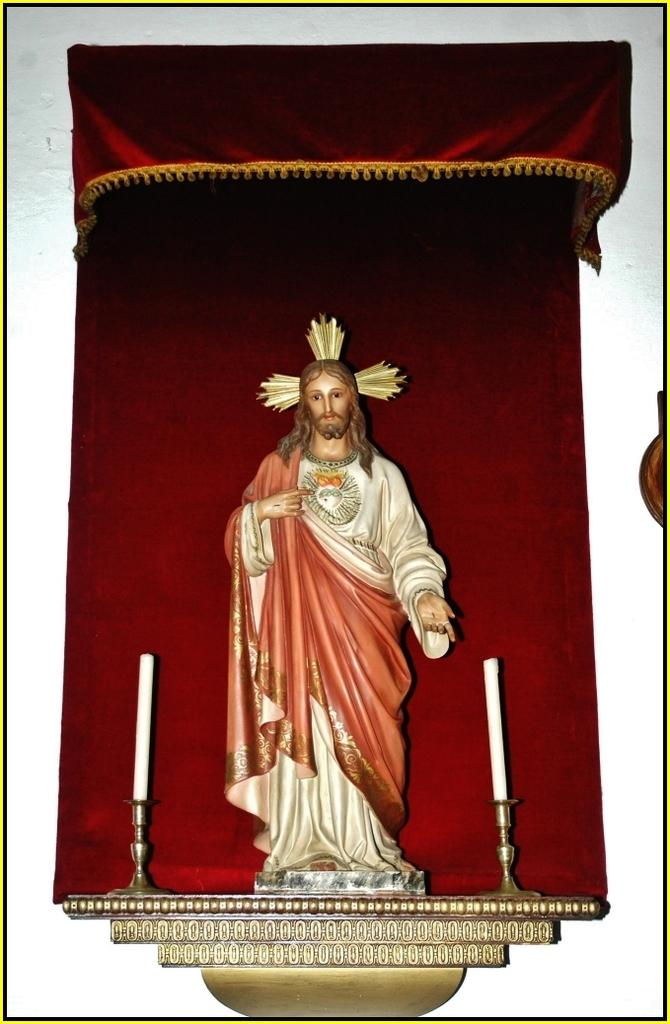What is the main subject in the center of the image? There is a statue in the center of the image. What is placed on each side of the statue? There is a candle on each side of the statue. What can be seen in the background of the image? There is a wall in the background of the image. What type of circle can be seen drawn with chalk on the statue in the image? There is no circle drawn with chalk on the statue in the image. Can you see any ants crawling on the statue in the image? There are no ants present in the image. 